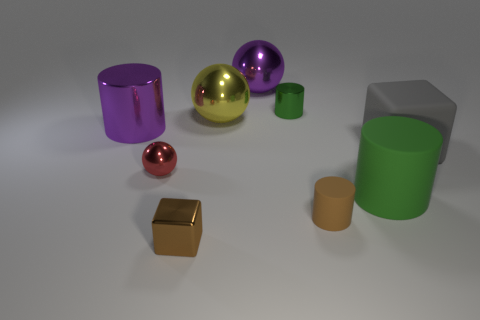Subtract 1 cylinders. How many cylinders are left? 3 Add 1 tiny brown cubes. How many objects exist? 10 Subtract all red cylinders. Subtract all green blocks. How many cylinders are left? 4 Subtract all cubes. How many objects are left? 7 Subtract 1 gray blocks. How many objects are left? 8 Subtract all small brown shiny things. Subtract all large cylinders. How many objects are left? 6 Add 4 metal cylinders. How many metal cylinders are left? 6 Add 4 blue shiny blocks. How many blue shiny blocks exist? 4 